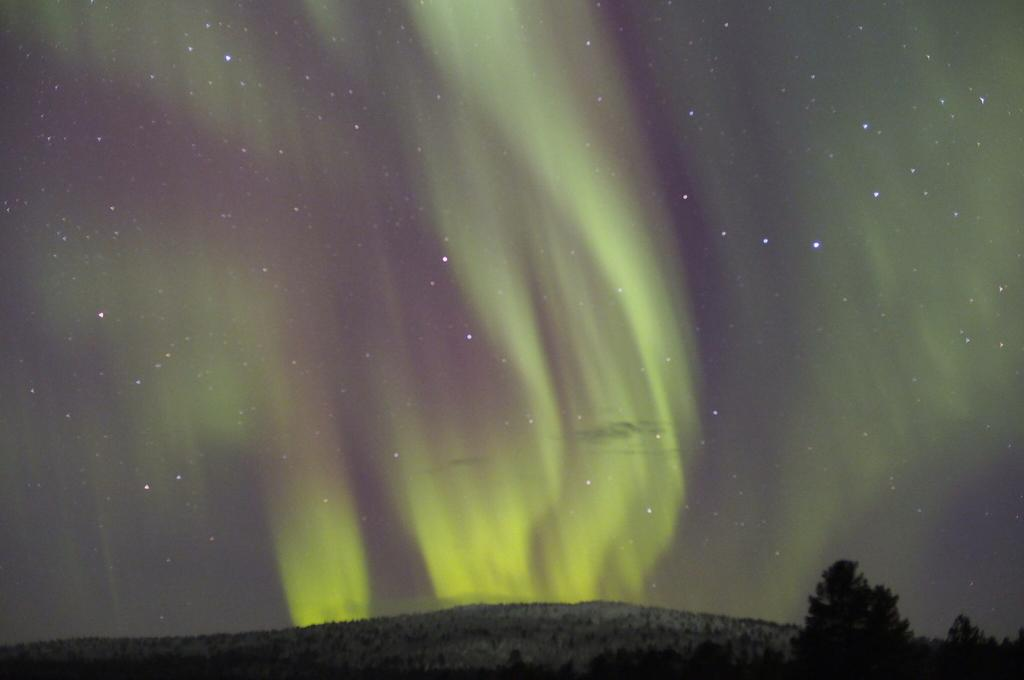What type of geographical feature is present in the image? There is a mountain in the image. What type of vegetation can be seen in the image? There are trees in the image. What celestial objects are visible in the image? Stars are visible in the sky in the image. What type of volcano can be seen erupting in the image? There is no volcano present in the image, nor is there any indication of an eruption. 